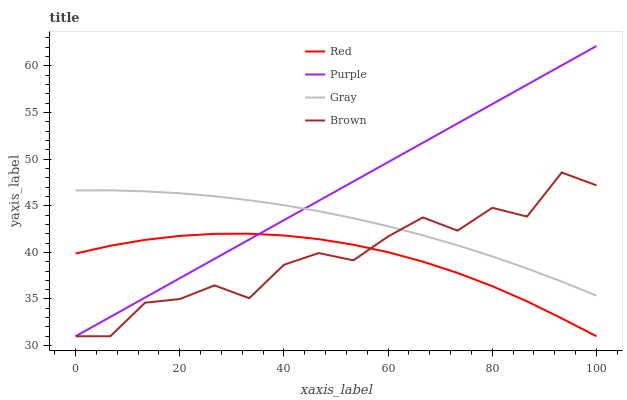Does Red have the minimum area under the curve?
Answer yes or no. Yes. Does Purple have the maximum area under the curve?
Answer yes or no. Yes. Does Gray have the minimum area under the curve?
Answer yes or no. No. Does Gray have the maximum area under the curve?
Answer yes or no. No. Is Purple the smoothest?
Answer yes or no. Yes. Is Brown the roughest?
Answer yes or no. Yes. Is Gray the smoothest?
Answer yes or no. No. Is Gray the roughest?
Answer yes or no. No. Does Purple have the lowest value?
Answer yes or no. Yes. Does Gray have the lowest value?
Answer yes or no. No. Does Purple have the highest value?
Answer yes or no. Yes. Does Gray have the highest value?
Answer yes or no. No. Is Red less than Gray?
Answer yes or no. Yes. Is Gray greater than Red?
Answer yes or no. Yes. Does Gray intersect Purple?
Answer yes or no. Yes. Is Gray less than Purple?
Answer yes or no. No. Is Gray greater than Purple?
Answer yes or no. No. Does Red intersect Gray?
Answer yes or no. No. 